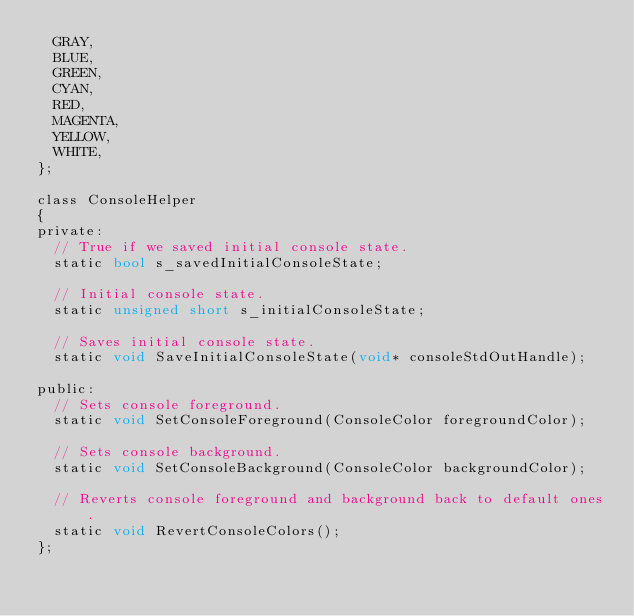Convert code to text. <code><loc_0><loc_0><loc_500><loc_500><_Cuda_>	GRAY,
	BLUE,
	GREEN,
	CYAN,
	RED,
	MAGENTA,
	YELLOW,
	WHITE,
};

class ConsoleHelper
{
private:
	// True if we saved initial console state.
	static bool s_savedInitialConsoleState;

	// Initial console state.
	static unsigned short s_initialConsoleState;

	// Saves initial console state.
	static void SaveInitialConsoleState(void* consoleStdOutHandle);

public:
	// Sets console foreground.
	static void SetConsoleForeground(ConsoleColor foregroundColor);

	// Sets console background.
	static void SetConsoleBackground(ConsoleColor backgroundColor);

	// Reverts console foreground and background back to default ones.
	static void RevertConsoleColors();
};</code> 